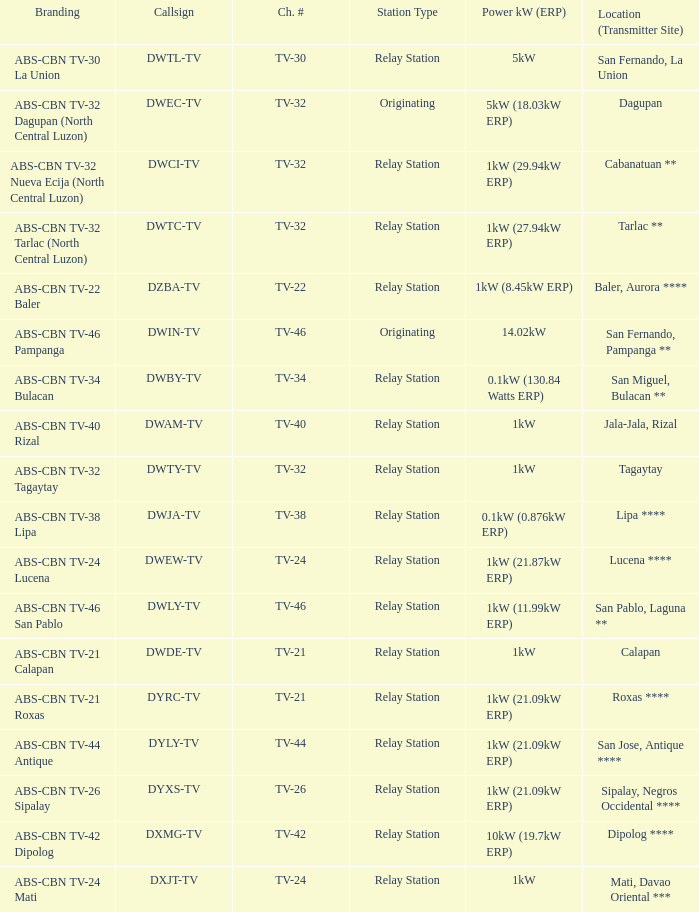How many brandings are there where the Power kW (ERP) is 1kW (29.94kW ERP)? 1.0. 